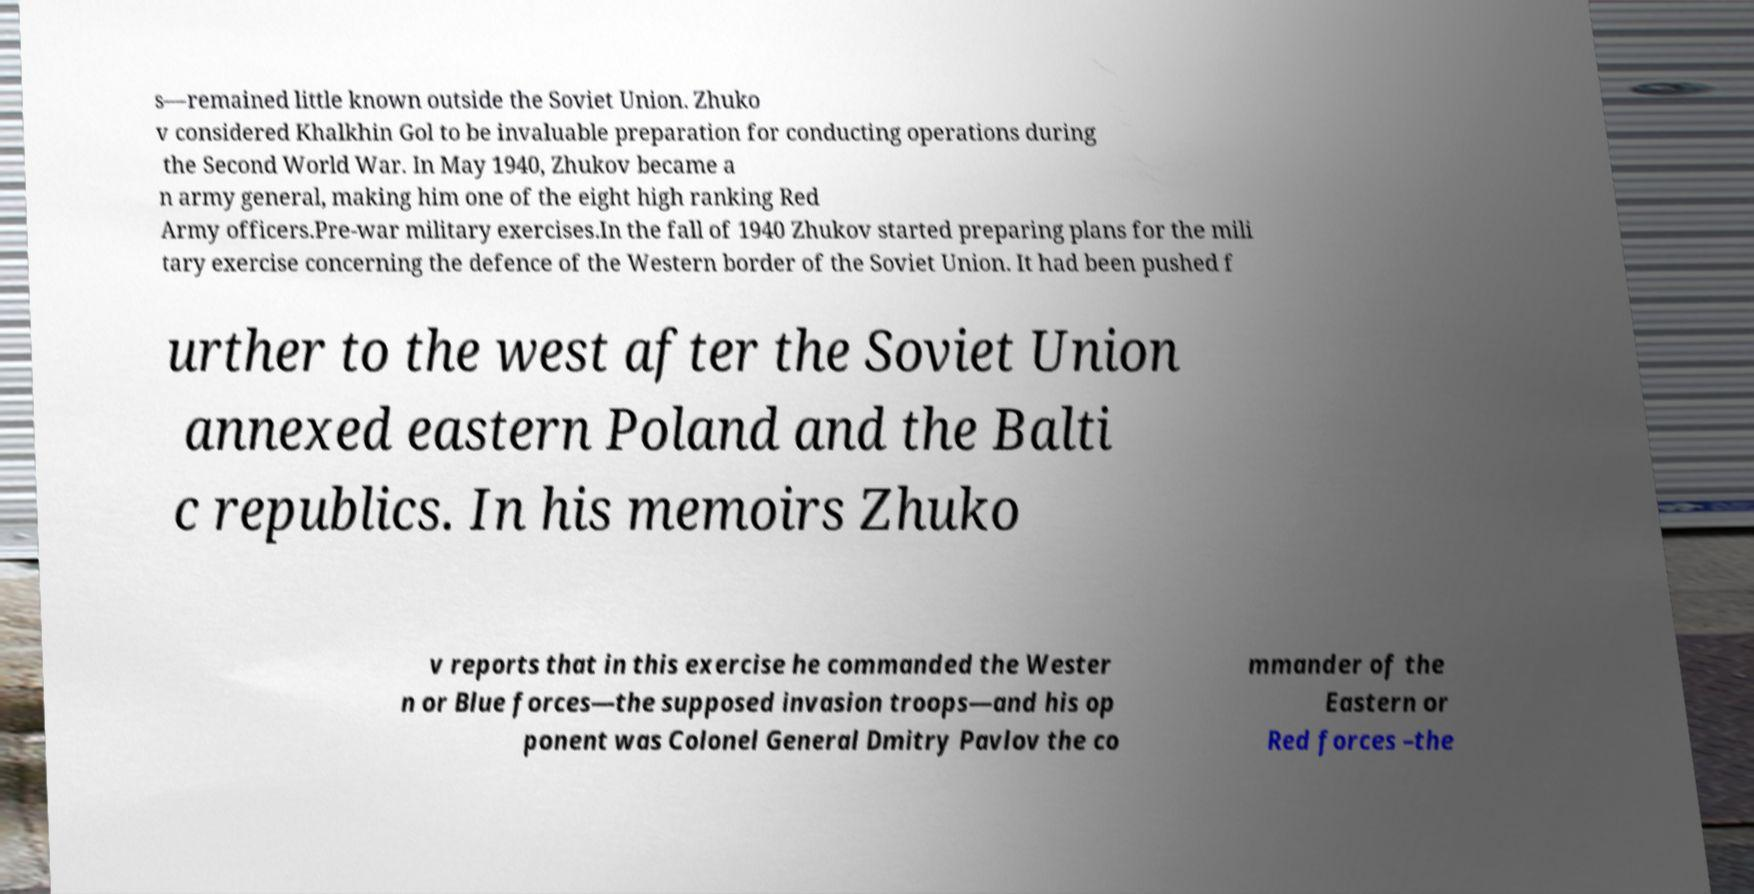Please read and relay the text visible in this image. What does it say? s—remained little known outside the Soviet Union. Zhuko v considered Khalkhin Gol to be invaluable preparation for conducting operations during the Second World War. In May 1940, Zhukov became a n army general, making him one of the eight high ranking Red Army officers.Pre-war military exercises.In the fall of 1940 Zhukov started preparing plans for the mili tary exercise concerning the defence of the Western border of the Soviet Union. It had been pushed f urther to the west after the Soviet Union annexed eastern Poland and the Balti c republics. In his memoirs Zhuko v reports that in this exercise he commanded the Wester n or Blue forces—the supposed invasion troops—and his op ponent was Colonel General Dmitry Pavlov the co mmander of the Eastern or Red forces –the 